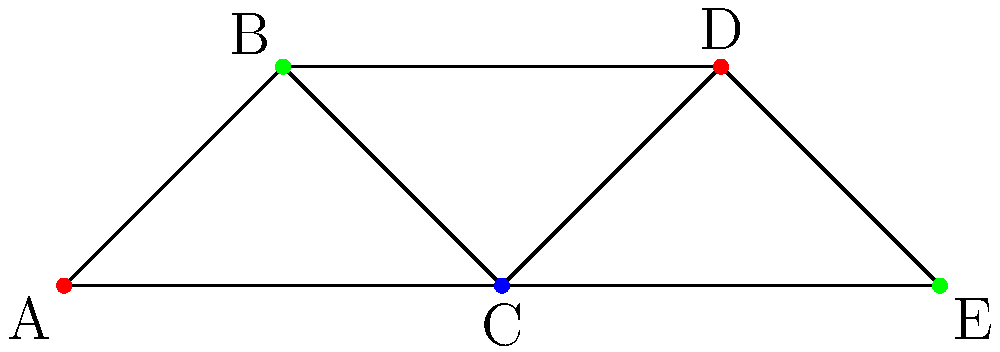As the lead cyclist in your team, you're helping to schedule training sessions for five key activities: A (Endurance), B (Sprinting), C (Climbing), D (Time Trial), and E (Recovery). To optimize the team's performance, activities connected by a line in the graph cannot be scheduled on the same day. Using graph coloring, what is the minimum number of days required to schedule all activities without conflicts? To solve this problem, we'll use graph coloring techniques. Each color represents a different day, and connected vertices (activities) must have different colors (days). Here's the step-by-step process:

1. Analyze the graph:
   - We have 5 vertices (A, B, C, D, E) representing different activities.
   - Edges connect activities that cannot be scheduled on the same day.

2. Apply the greedy coloring algorithm:
   - Start with vertex A and assign it the first color (red).
   - Move to B, which is connected to A. Assign it a new color (green).
   - For C, it's connected to A and B, so we need a third color (blue).
   - D is connected to B and C, but not A, so we can use A's color (red).
   - E is connected to C and D, so we can use B's color (green).

3. Count the number of colors used:
   - We used 3 colors in total: red, green, and blue.

4. Interpret the result:
   - Each color represents a day in the schedule.
   - Activities with the same color can be scheduled on the same day.
   - We need a minimum of 3 days to schedule all activities without conflicts.

The coloring shown in the graph is an optimal solution, demonstrating that 3 is indeed the minimum number of days required.
Answer: 3 days 